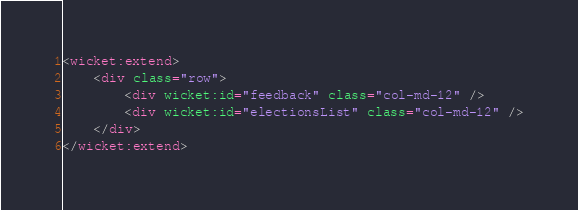<code> <loc_0><loc_0><loc_500><loc_500><_HTML_><wicket:extend>
	<div class="row">
		<div wicket:id="feedback" class="col-md-12" />
		<div wicket:id="electionsList" class="col-md-12" />
	</div>
</wicket:extend></code> 